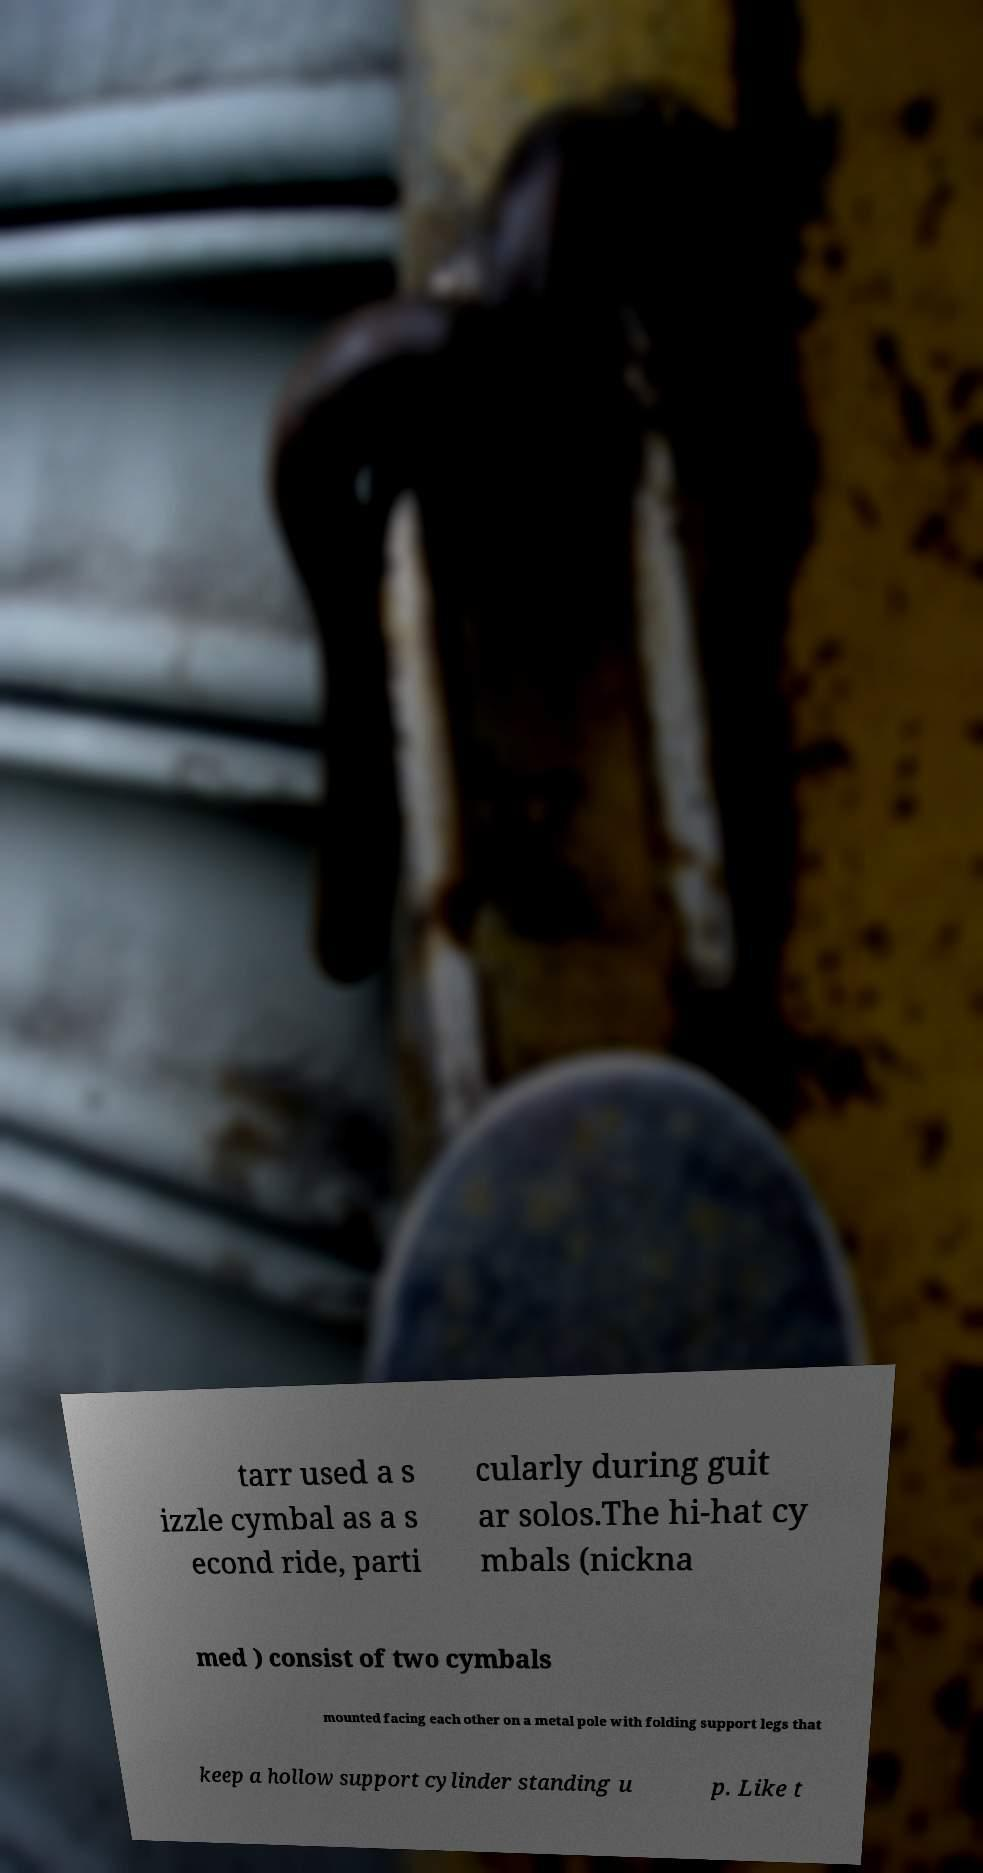Could you extract and type out the text from this image? tarr used a s izzle cymbal as a s econd ride, parti cularly during guit ar solos.The hi-hat cy mbals (nickna med ) consist of two cymbals mounted facing each other on a metal pole with folding support legs that keep a hollow support cylinder standing u p. Like t 